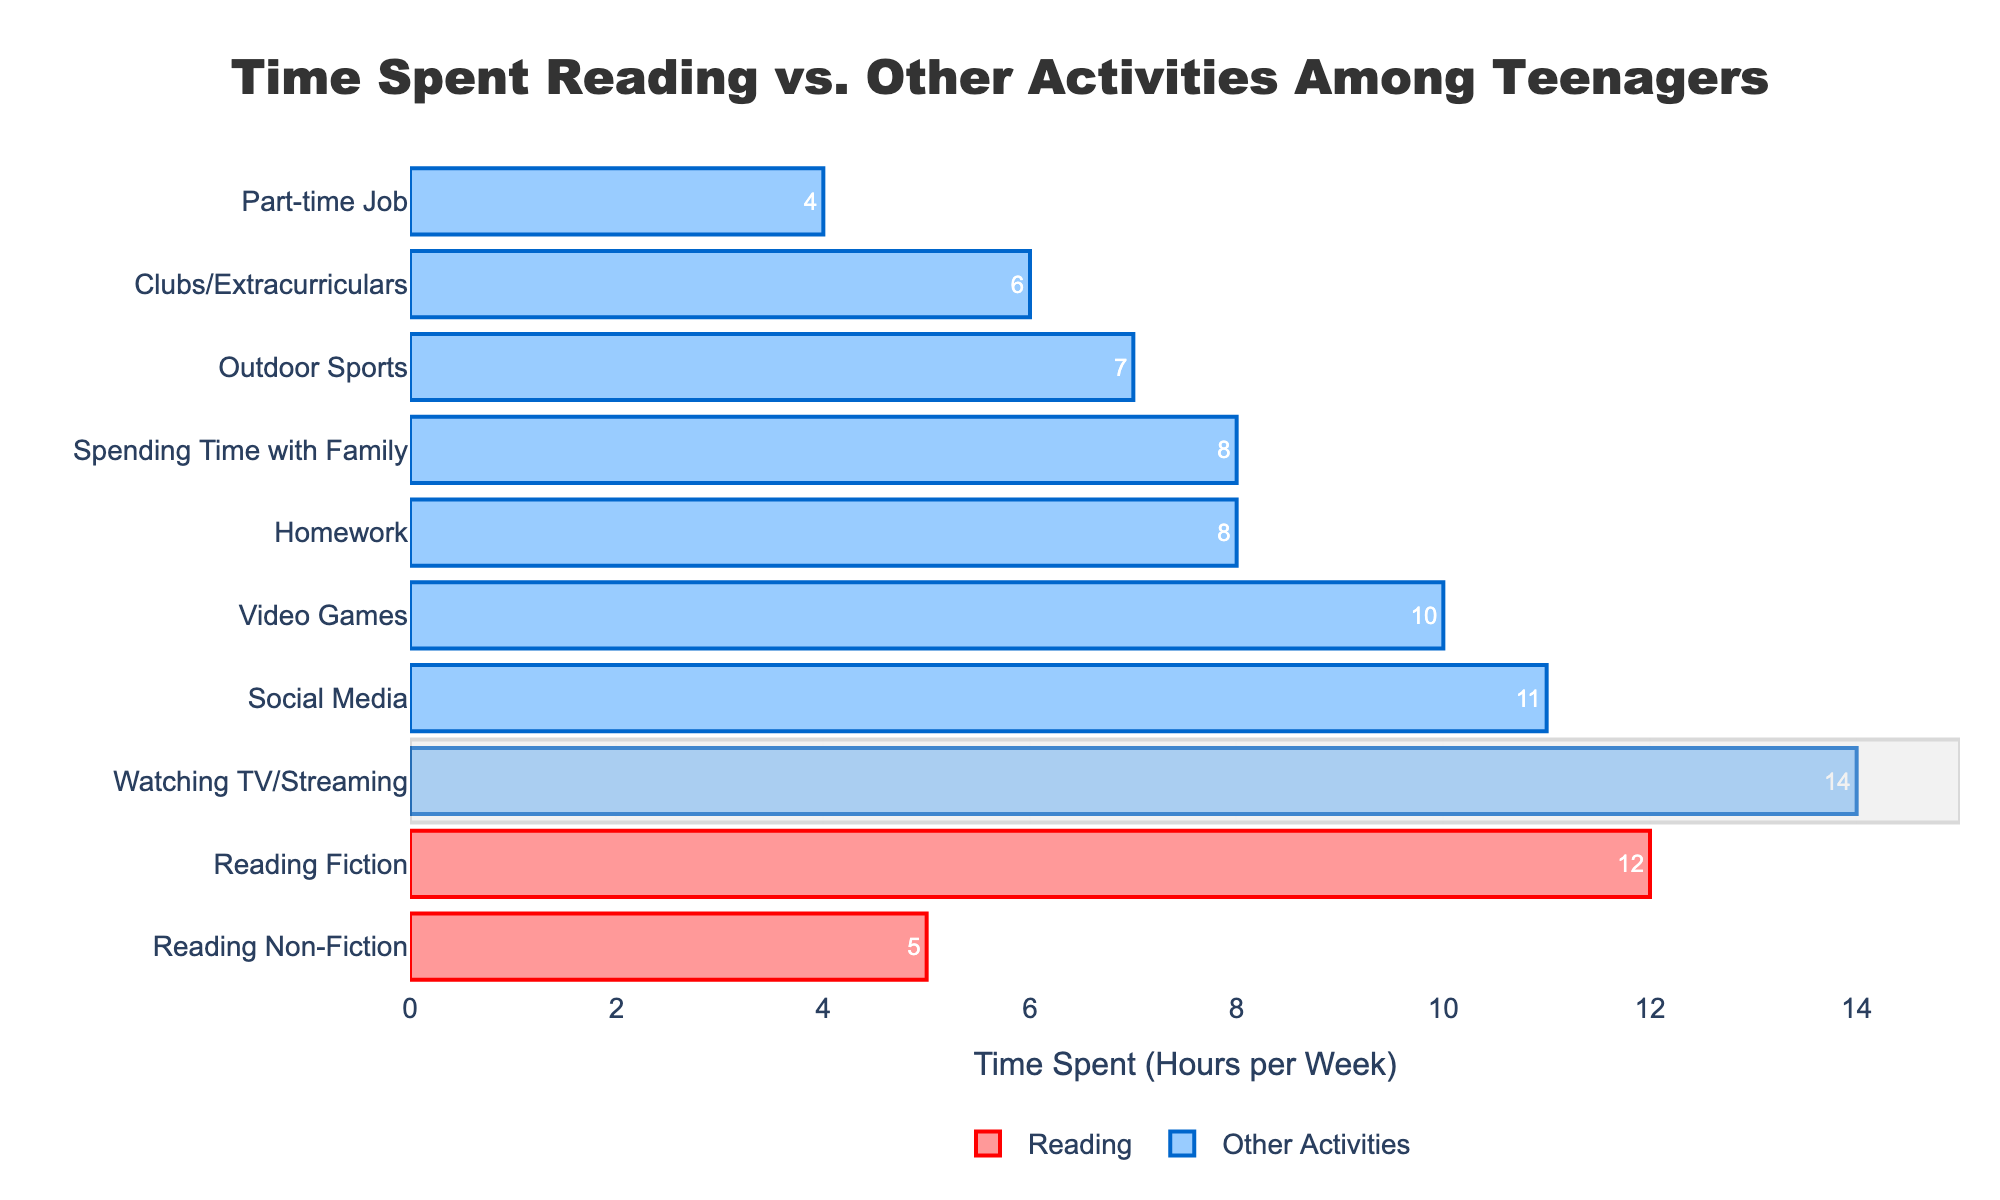Which activity do teenagers spend the most time on? According to the chart, the longest bar indicates the activity where teenagers spend the most time. The longest bar represents "Watching TV/Streaming" with 14 hours per week.
Answer: Watching TV/Streaming How many hours do teenagers spend on reading activities in total? To find the total time spent on reading activities, sum the hours spent on reading fiction and reading non-fiction. Reading Fiction is 12 hours and Reading Non-Fiction is 5 hours, so the total is 12 + 5 = 17 hours per week.
Answer: 17 Which activity has more time spent: Social Media or Video Games? Compare the lengths of the bars for "Social Media" and "Video Games". "Social Media" is 11 hours, and "Video Games" is 10 hours.
Answer: Social Media What is the difference in time spent between Homework and Spending Time with Family? Find the bars labeled "Homework" and "Spending Time with Family". "Homework" is 8 hours and "Spending Time with Family" is also 8 hours. The difference is 0 hours.
Answer: 0 What percentage of total time spent on "Other Activities" is spent watching TV/Streaming? First, total the time spent on all "Other Activities" by adding hours for: Homework (8) + Video Games (10) + Watching TV/Streaming (14) + Social Media (11) + Clubs/Extracurriculars (6) + Outdoor Sports (7) + Spending Time with Family (8) + Part-time Job (4), which equals 68 hours. Then, calculate the percentage for "Watching TV/Streaming": (14 / 68) * 100 ≈ 20.59%.
Answer: ≈ 20.59% What is the average time spent on reading activities? Calculate the average by adding time for both reading activities (Reading Fiction: 12, Reading Non-Fiction: 5) and then dividing by the number of reading activities, so (12 + 5) / 2 = 8.5 hours.
Answer: 8.5 Which activity in the "Other Activities" category has the least time spent? Look for the shortest bar in the "Other Activities" section, which represents "Part-time Job" with 4 hours.
Answer: Part-time Job Is the total time spent on "Outdoor Sports" and "Clubs/Extracurriculars" greater than the time spent on "Social Media"? Sum the time for "Outdoor Sports" (7) and "Clubs/Extracurriculars" (6), which is 7 + 6 = 13 hours. Compare with "Social Media", which is 11 hours. Since 13 > 11, the answer is yes.
Answer: Yes What is the ratio of time spent on "Reading Fiction" to "Reading Non-Fiction"? Divide the time for "Reading Fiction" by "Reading Non-Fiction": 12 hours / 5 hours = 2.4.
Answer: 2.4 